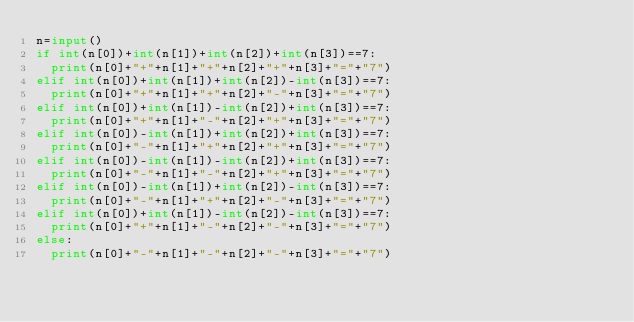Convert code to text. <code><loc_0><loc_0><loc_500><loc_500><_Python_>n=input()
if int(n[0])+int(n[1])+int(n[2])+int(n[3])==7:
  print(n[0]+"+"+n[1]+"+"+n[2]+"+"+n[3]+"="+"7")
elif int(n[0])+int(n[1])+int(n[2])-int(n[3])==7:
  print(n[0]+"+"+n[1]+"+"+n[2]+"-"+n[3]+"="+"7")
elif int(n[0])+int(n[1])-int(n[2])+int(n[3])==7:
  print(n[0]+"+"+n[1]+"-"+n[2]+"+"+n[3]+"="+"7")
elif int(n[0])-int(n[1])+int(n[2])+int(n[3])==7:
  print(n[0]+"-"+n[1]+"+"+n[2]+"+"+n[3]+"="+"7")
elif int(n[0])-int(n[1])-int(n[2])+int(n[3])==7:
  print(n[0]+"-"+n[1]+"-"+n[2]+"+"+n[3]+"="+"7")
elif int(n[0])-int(n[1])+int(n[2])-int(n[3])==7:
  print(n[0]+"-"+n[1]+"+"+n[2]+"-"+n[3]+"="+"7")
elif int(n[0])+int(n[1])-int(n[2])-int(n[3])==7:
  print(n[0]+"+"+n[1]+"-"+n[2]+"-"+n[3]+"="+"7")
else:
  print(n[0]+"-"+n[1]+"-"+n[2]+"-"+n[3]+"="+"7")</code> 